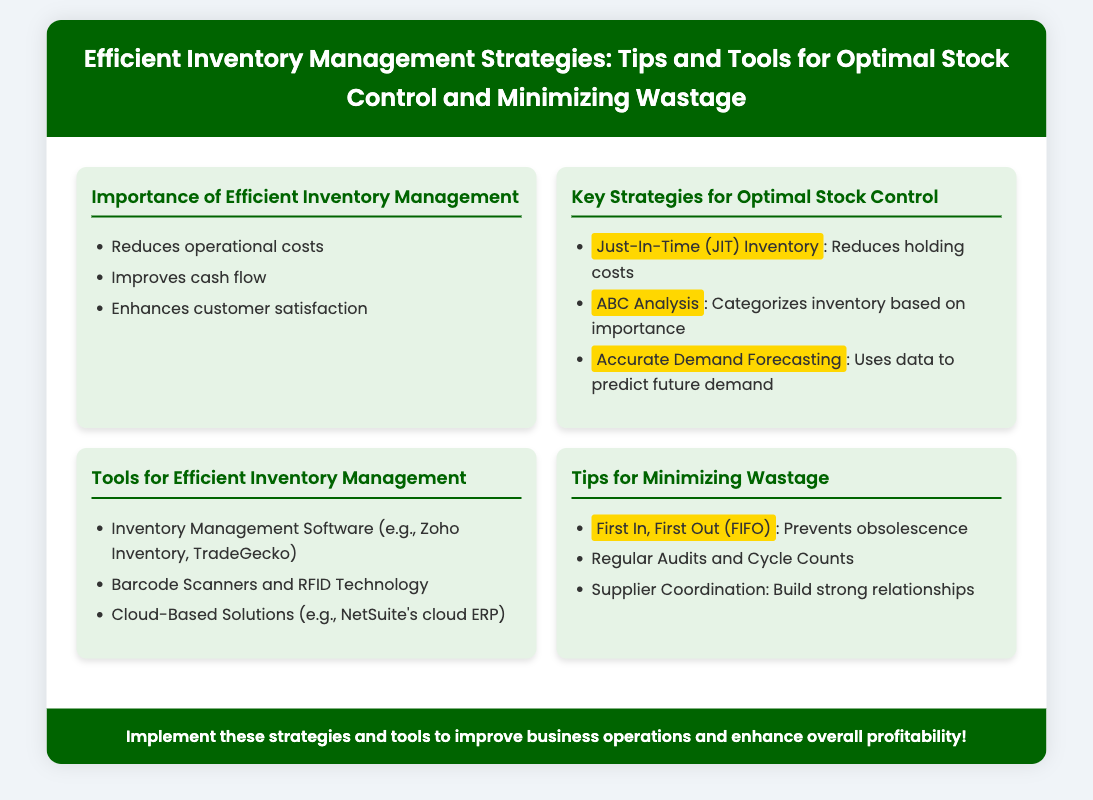What is the title of the presentation? The title is prominently displayed at the top of the document.
Answer: Efficient Inventory Management Strategies: Tips and Tools for Optimal Stock Control and Minimizing Wastage What is the first strategy mentioned for optimal stock control? The first strategy is listed under the key strategies section.
Answer: Just-In-Time (JIT) Inventory What tool for efficient inventory management is an example of cloud-based solutions? This information is found in the tools section of the document.
Answer: NetSuite's cloud ERP What does FIFO stand for? This acronym is used in the tips for minimizing wastage section.
Answer: First In, First Out How many key strategies are mentioned for optimal stock control? The number of strategies can be counted from the list in the document.
Answer: Three 